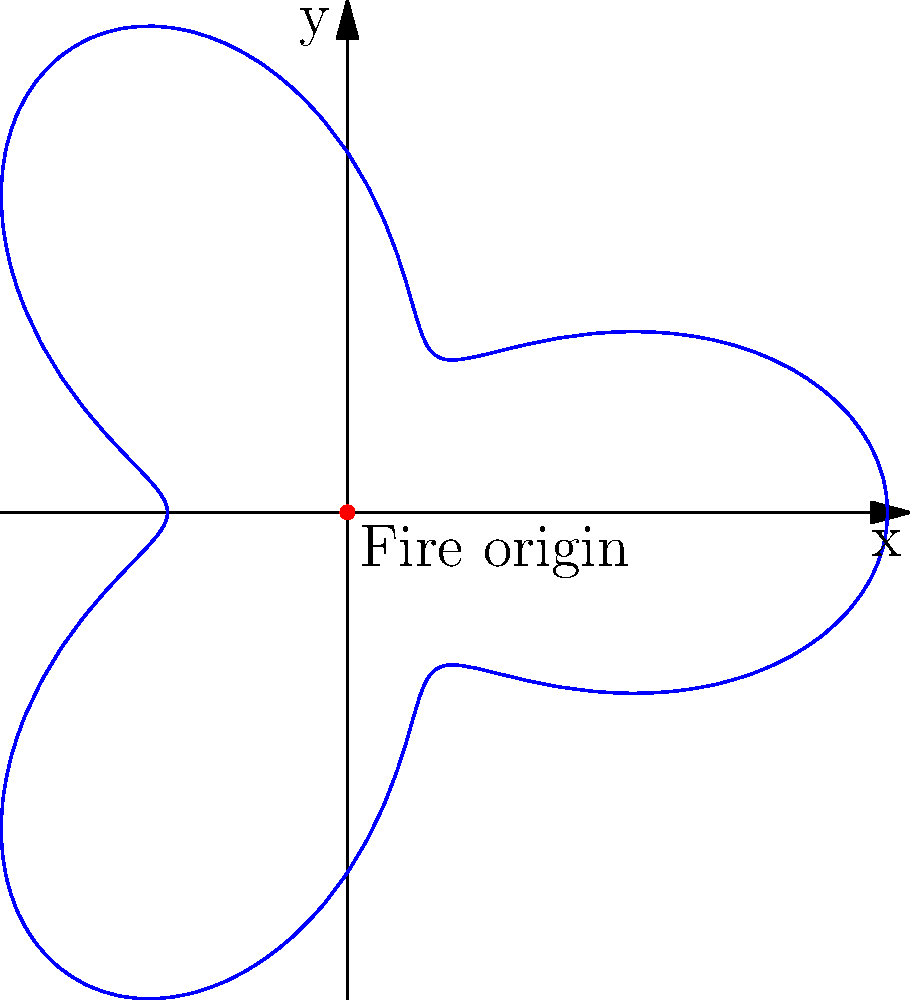A forest fire has started at the origin of a polar coordinate system. The fire's spread pattern is modeled by the equation $r = 2 + \cos(3\theta)$, where $r$ is the distance from the origin in kilometers and $\theta$ is the angle in radians. What is the maximum distance the fire spreads from its origin? To find the maximum distance the fire spreads from its origin, we need to determine the maximum value of $r$ in the given equation:

1) The equation for the fire spread is $r = 2 + \cos(3\theta)$

2) We know that the cosine function oscillates between -1 and 1

3) The maximum value of $\cos(3\theta)$ is 1

4) Therefore, the maximum value of $r$ occurs when $\cos(3\theta) = 1$

5) Substituting this into the original equation:
   $r_{max} = 2 + 1 = 3$

6) Thus, the maximum distance the fire spreads from its origin is 3 kilometers

This result shows the resilience of the forest ecosystem, as the fire's spread is limited, allowing some areas to remain untouched and serve as seed sources for regeneration.
Answer: 3 kilometers 